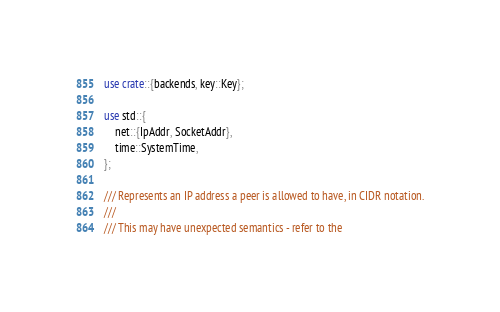Convert code to text. <code><loc_0><loc_0><loc_500><loc_500><_Rust_>use crate::{backends, key::Key};

use std::{
    net::{IpAddr, SocketAddr},
    time::SystemTime,
};

/// Represents an IP address a peer is allowed to have, in CIDR notation.
///
/// This may have unexpected semantics - refer to the</code> 